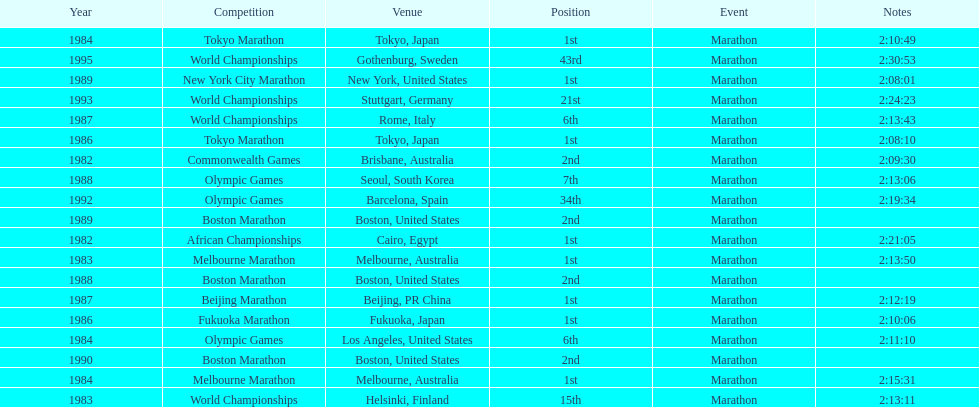What are the total number of times the position of 1st place was earned? 8. 